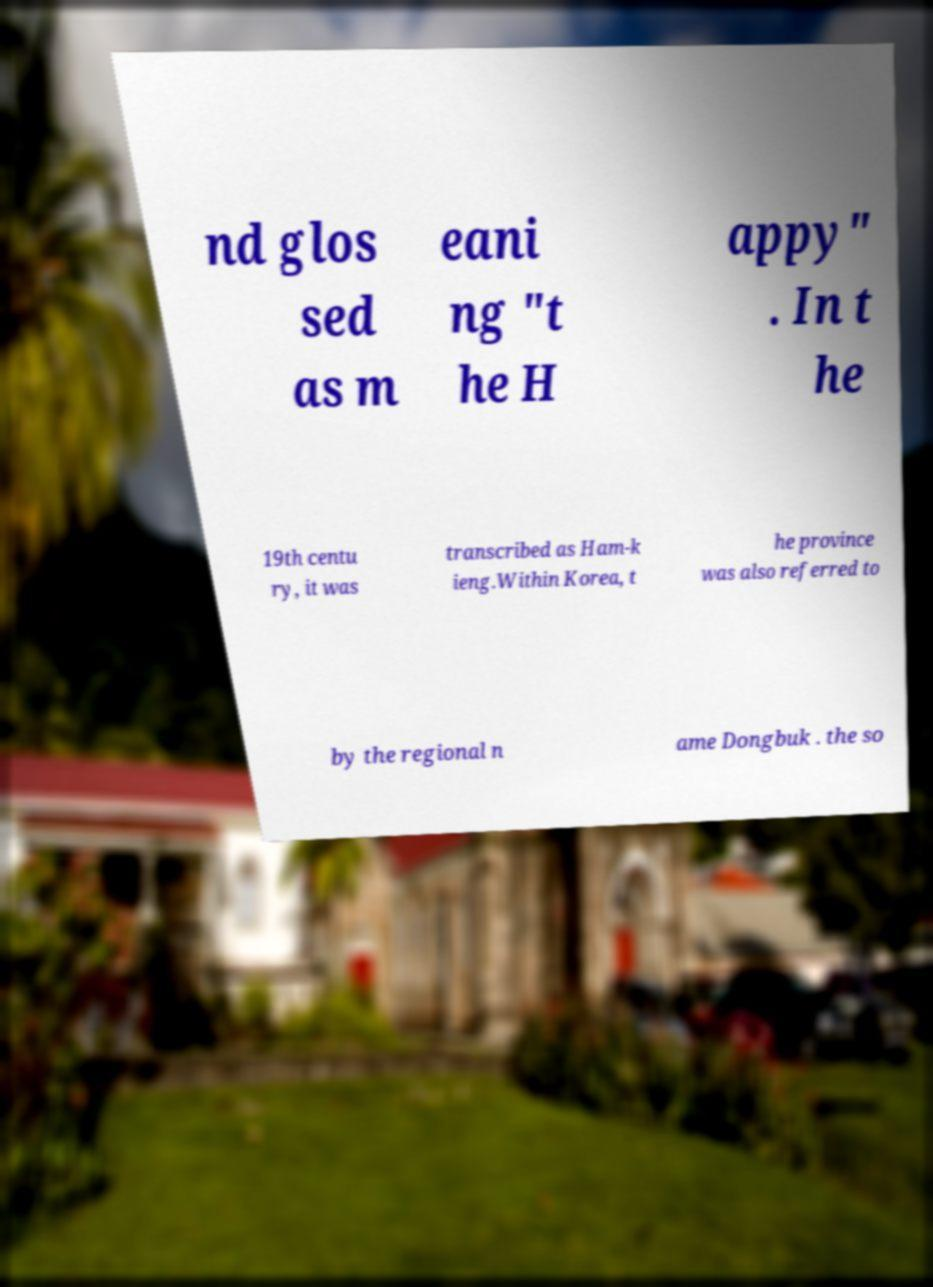Can you accurately transcribe the text from the provided image for me? nd glos sed as m eani ng "t he H appy" . In t he 19th centu ry, it was transcribed as Ham-k ieng.Within Korea, t he province was also referred to by the regional n ame Dongbuk . the so 